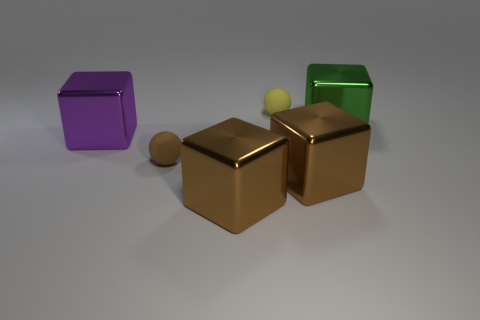There is a small ball that is the same material as the small yellow thing; what color is it?
Your response must be concise. Brown. How many yellow balls have the same material as the big purple cube?
Make the answer very short. 0. How many things are either red matte cylinders or blocks behind the small brown rubber object?
Provide a short and direct response. 2. Is the material of the tiny sphere that is left of the small yellow matte object the same as the green block?
Offer a terse response. No. What is the color of the other rubber ball that is the same size as the yellow ball?
Your answer should be compact. Brown. Are there any red things of the same shape as the large green thing?
Ensure brevity in your answer.  No. The big thing on the right side of the big brown block on the right side of the tiny ball that is behind the purple cube is what color?
Your response must be concise. Green. How many rubber objects are either big gray things or brown objects?
Provide a succinct answer. 1. Are there more metal cubes right of the brown ball than large brown shiny things that are to the left of the green thing?
Offer a terse response. Yes. What number of other objects are the same size as the yellow ball?
Make the answer very short. 1. 